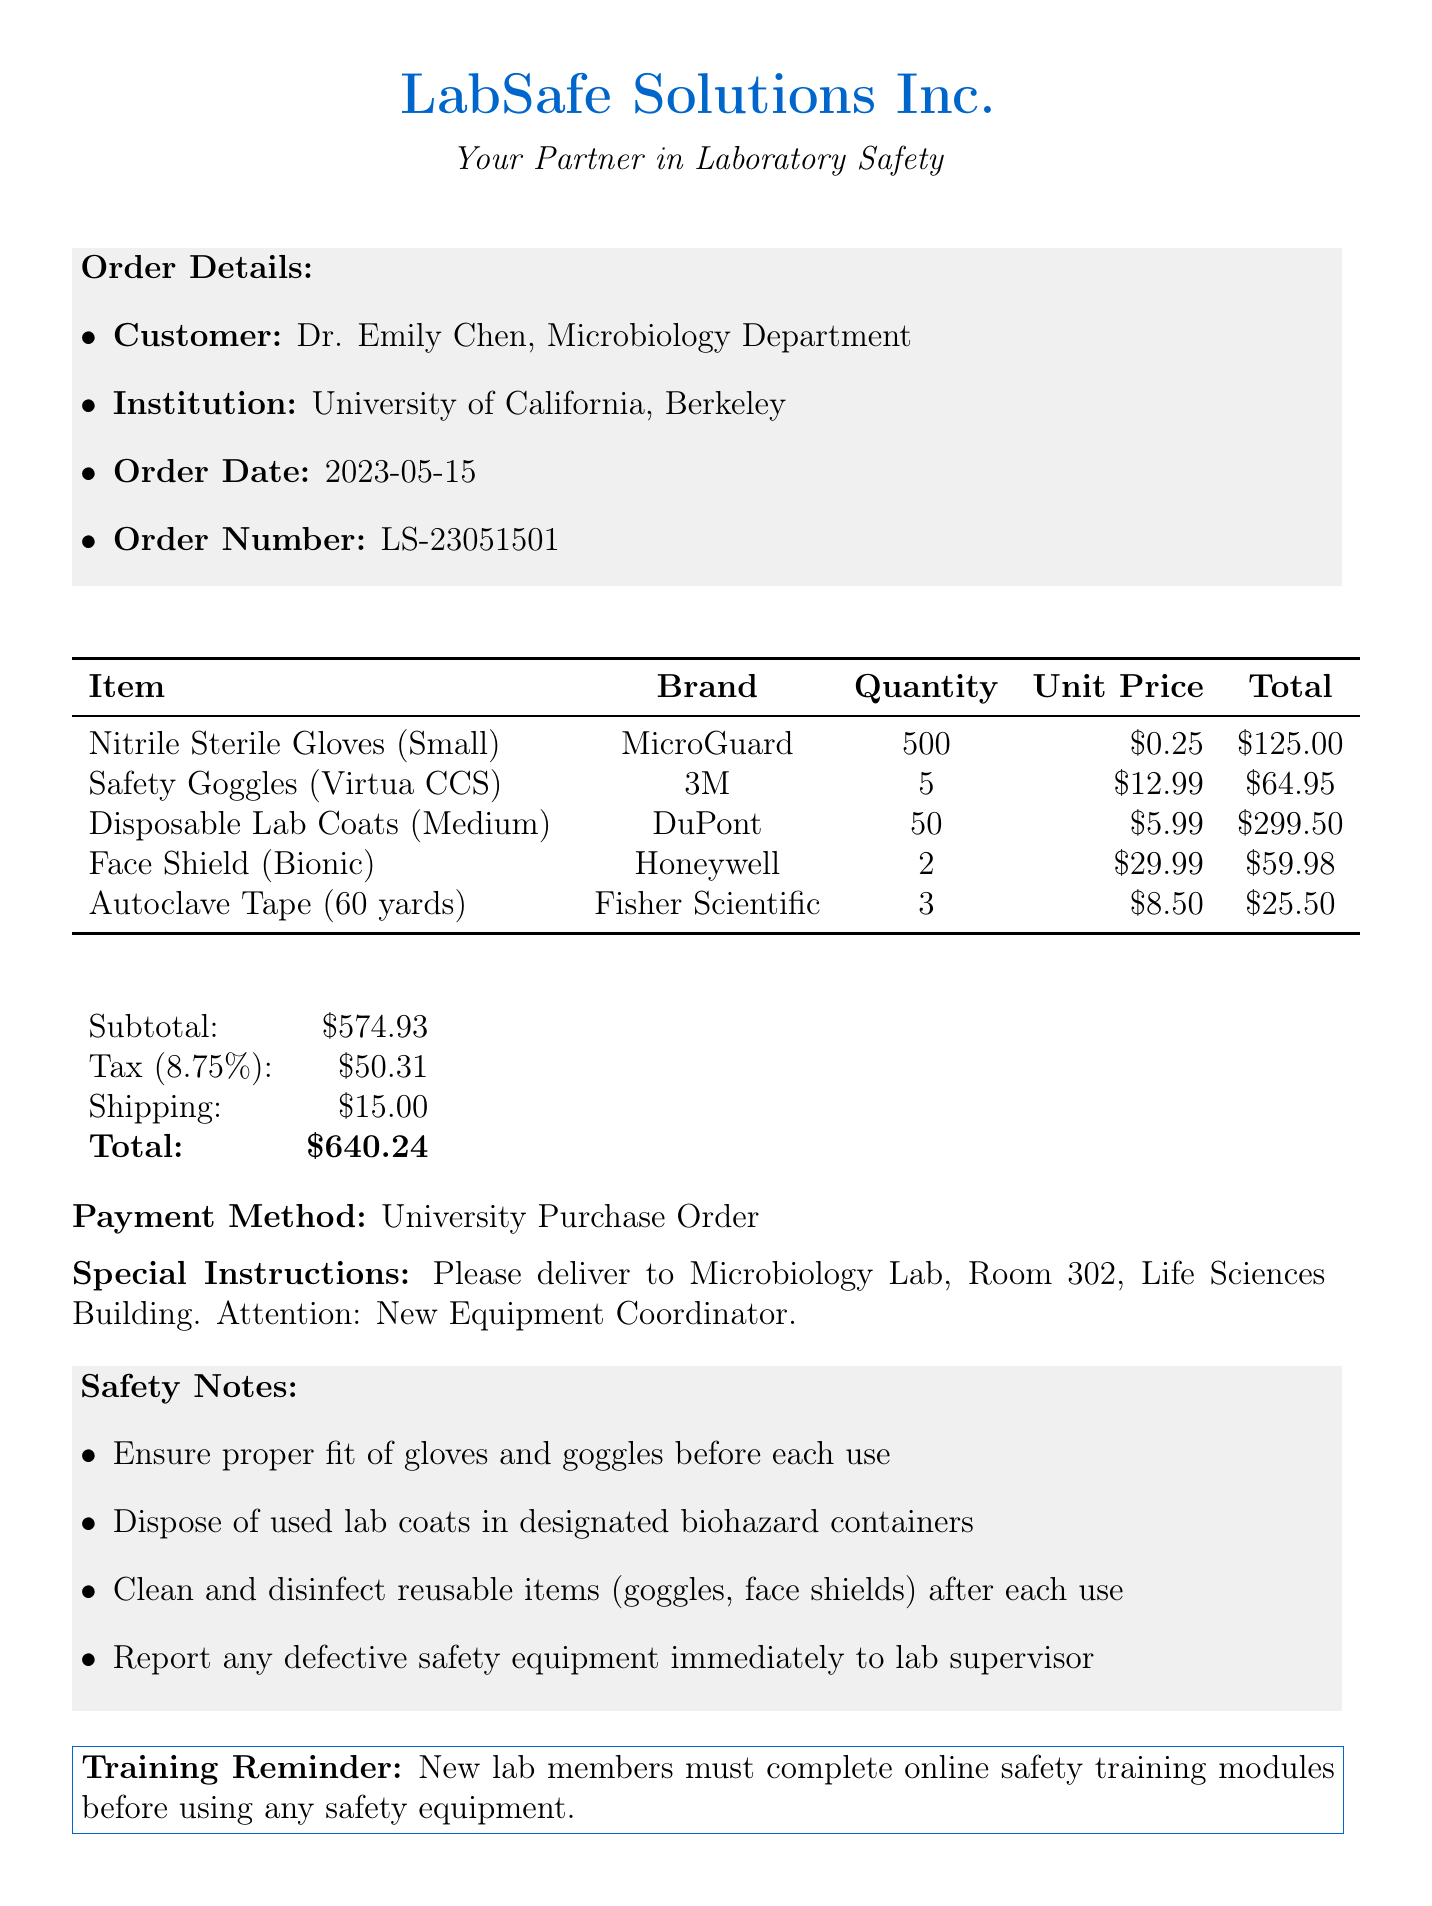What is the name of the supplier? The supplier of the lab safety gear is listed in the document under the supplier section.
Answer: LabSafe Solutions Inc What is the order date? The order date is identified explicitly under the order details section of the document.
Answer: 2023-05-15 How many pairs of nitrile sterile gloves were ordered? The quantity of nitrile sterile gloves is clearly stated in the items section of the document.
Answer: 500 What is the tax amount? The tax amount is specified in the financial summary section of the document that outlines the charges.
Answer: 50.31 What is the total amount for the order? The total amount is summarized at the end of the itemized list in the document.
Answer: 640.24 What safety equipment brand is associated with the goggles? The brand of safety goggles is mentioned next to the item name in the items section.
Answer: 3M How should used lab coats be disposed of? Instructions for proper disposal can be found in the safety notes section of the document.
Answer: Designated biohazard containers What is the size of the disposable lab coats ordered? The size of the disposable lab coats is mentioned in the items section of the document.
Answer: Medium What is the payment method used for this order? The payment method is explicitly stated in the financial summary section of the document.
Answer: University Purchase Order 